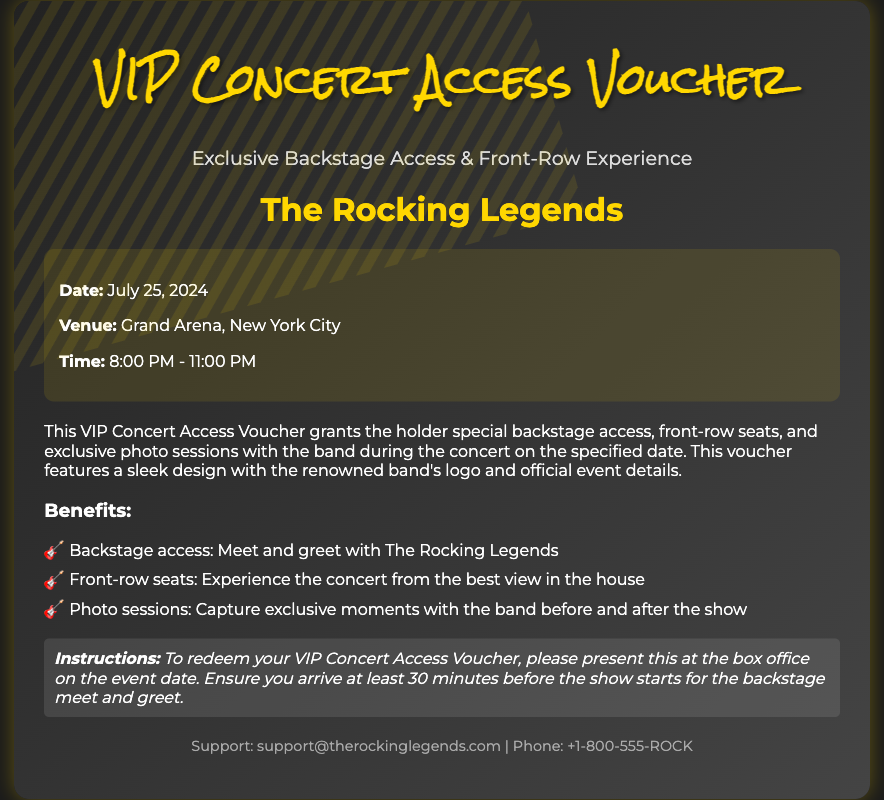What is the title of the voucher? The title of the voucher is prominently displayed at the top of the document.
Answer: VIP Concert Access Voucher What is the date of the concert? The date of the concert is mentioned in the event details section of the document.
Answer: July 25, 2024 Where is the concert taking place? The venue for the concert is specified in the event details section.
Answer: Grand Arena, New York City What time does the concert start? The start time of the concert is included in the event details section.
Answer: 8:00 PM What type of access does the voucher provide? The voucher grants specific access privileges that are listed in the document.
Answer: Backstage access How many benefits are listed in the document? The number of benefits can be counted from the benefits section.
Answer: Three What should you do to redeem the voucher? The instructions for redemption are provided in the document.
Answer: Present at the box office What is the email for support? The support contact information is included at the bottom of the voucher.
Answer: support@therockinglegends.com What kind of experience is highlighted in the subtitle? The subtitle emphasizes the nature of the experience provided by the voucher.
Answer: Exclusive Backstage Access & Front-Row Experience 